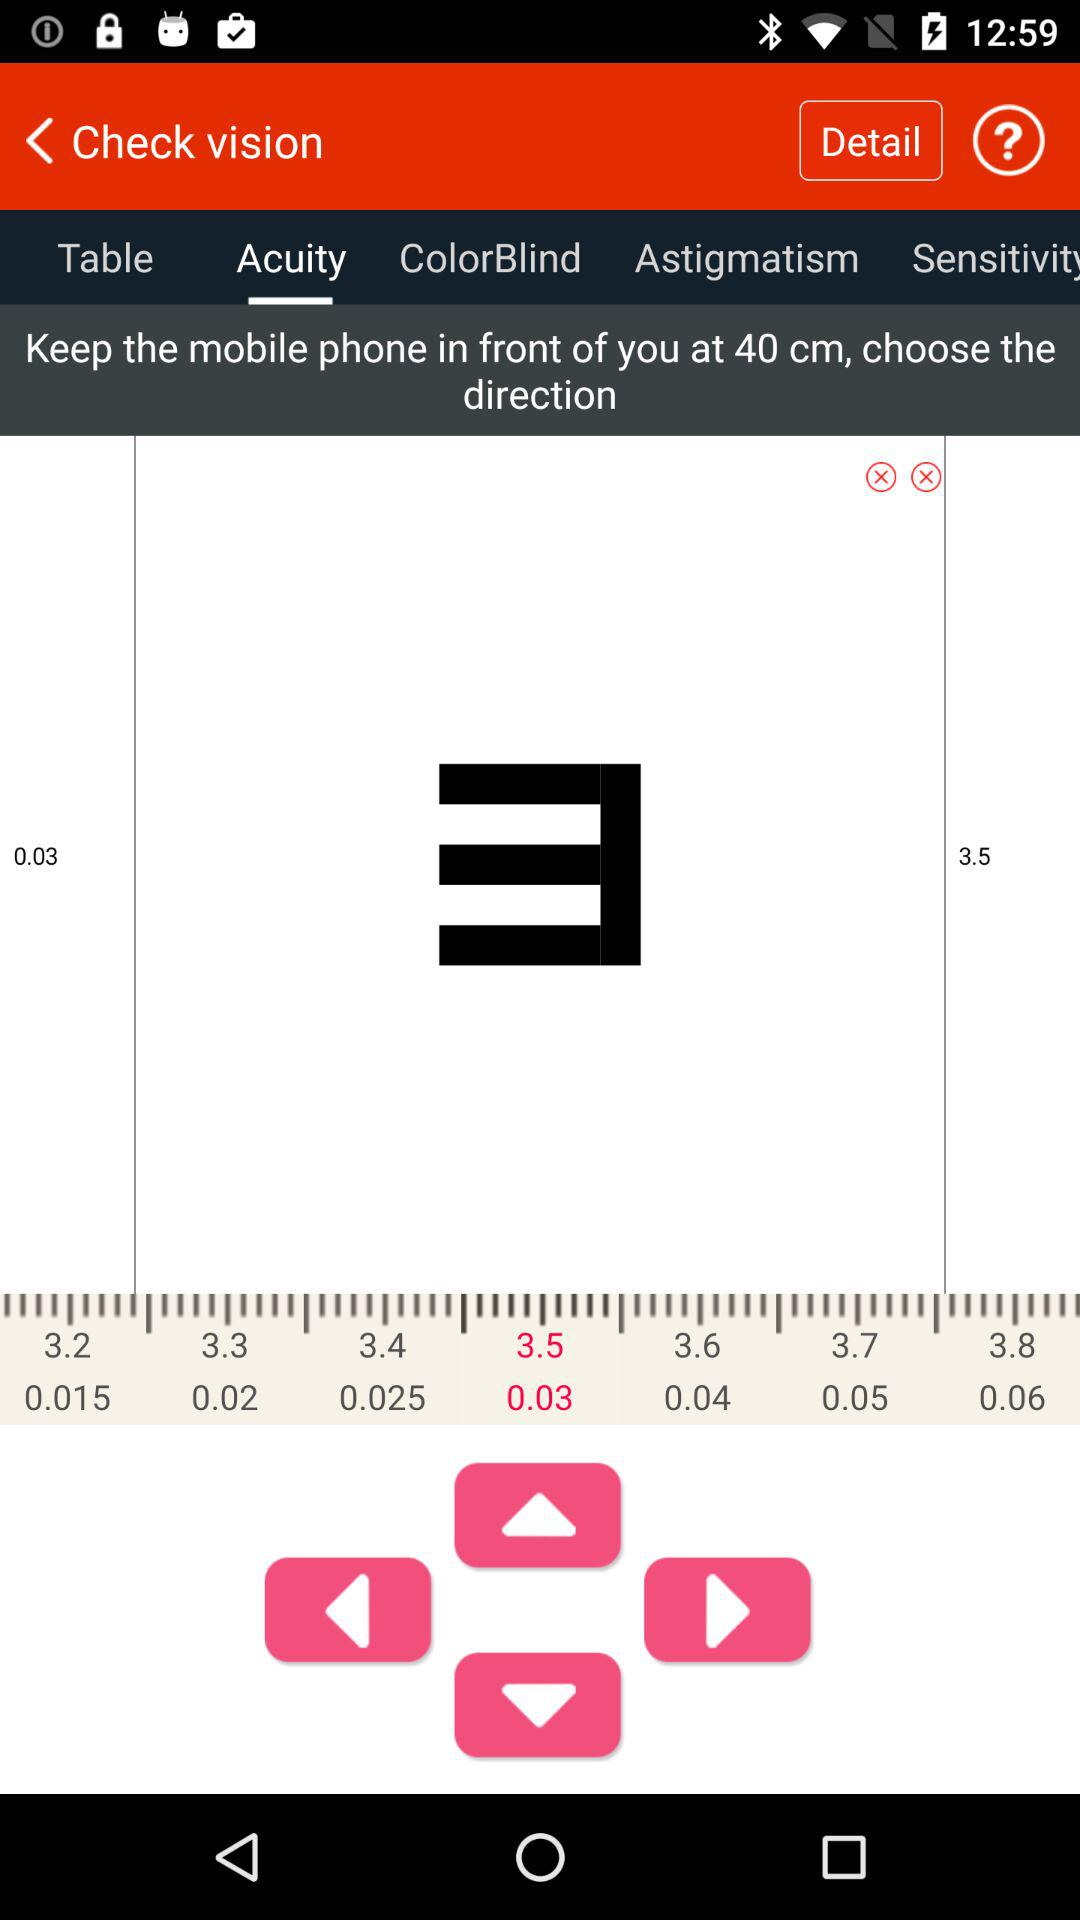Which direction is chosen?
When the provided information is insufficient, respond with <no answer>. <no answer> 